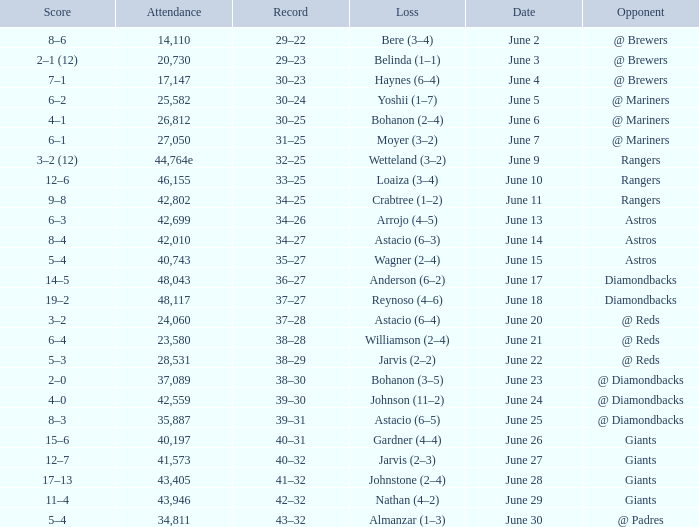What's the record when the attendance was 41,573? 40–32. 